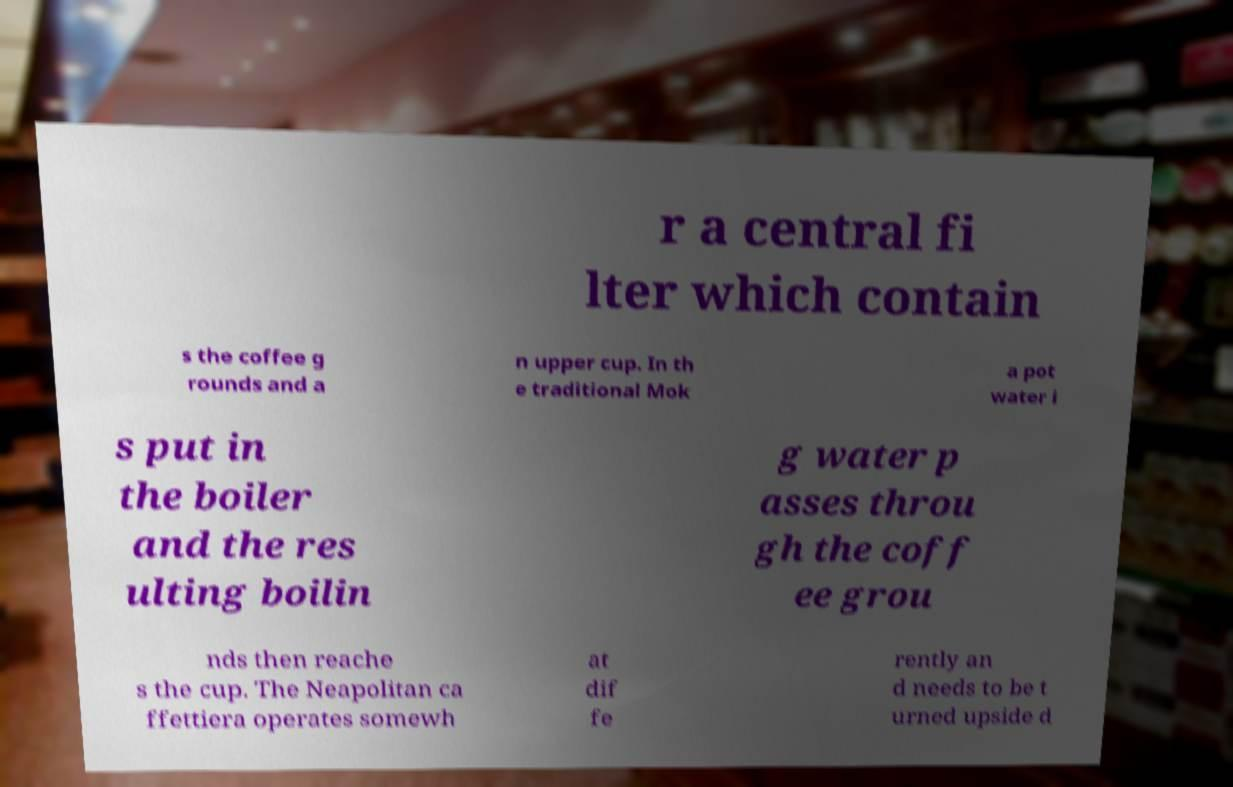I need the written content from this picture converted into text. Can you do that? r a central fi lter which contain s the coffee g rounds and a n upper cup. In th e traditional Mok a pot water i s put in the boiler and the res ulting boilin g water p asses throu gh the coff ee grou nds then reache s the cup. The Neapolitan ca ffettiera operates somewh at dif fe rently an d needs to be t urned upside d 